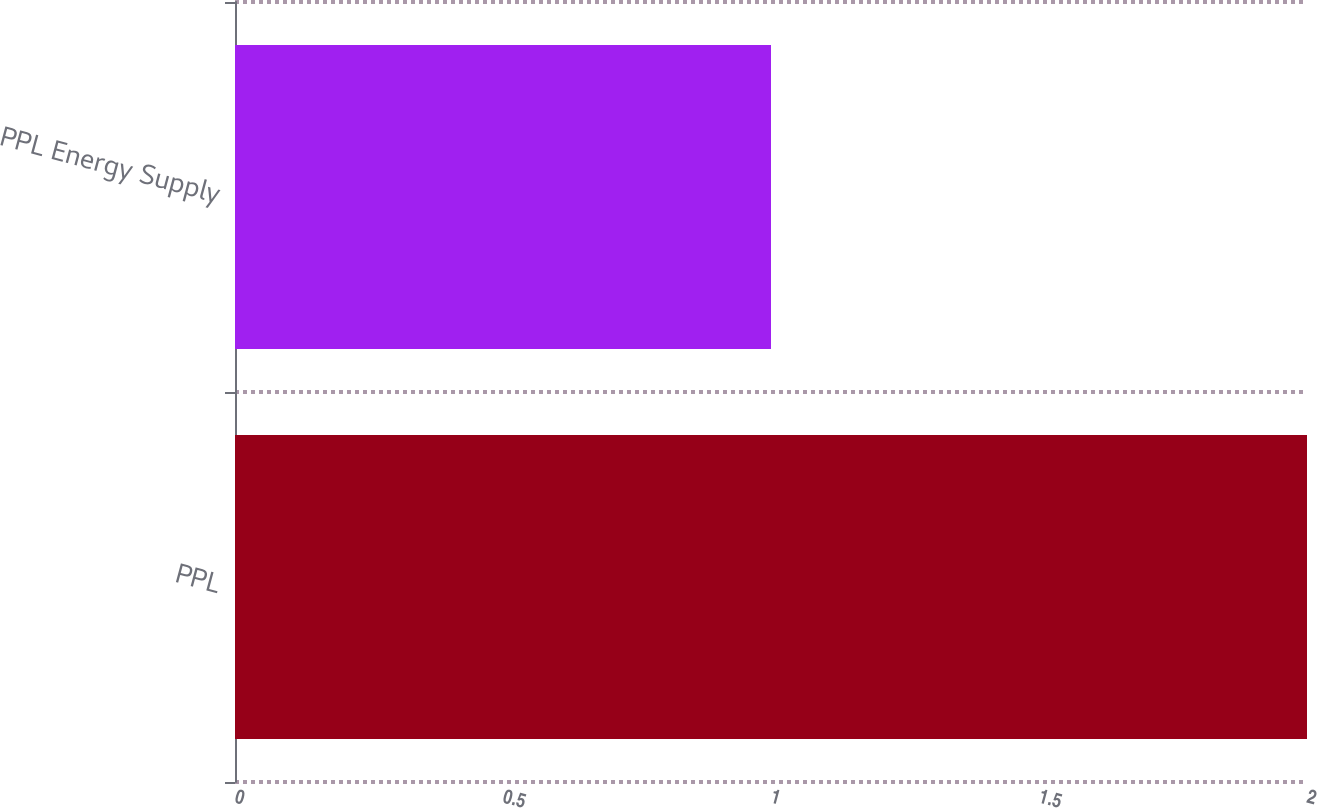Convert chart. <chart><loc_0><loc_0><loc_500><loc_500><bar_chart><fcel>PPL<fcel>PPL Energy Supply<nl><fcel>2<fcel>1<nl></chart> 